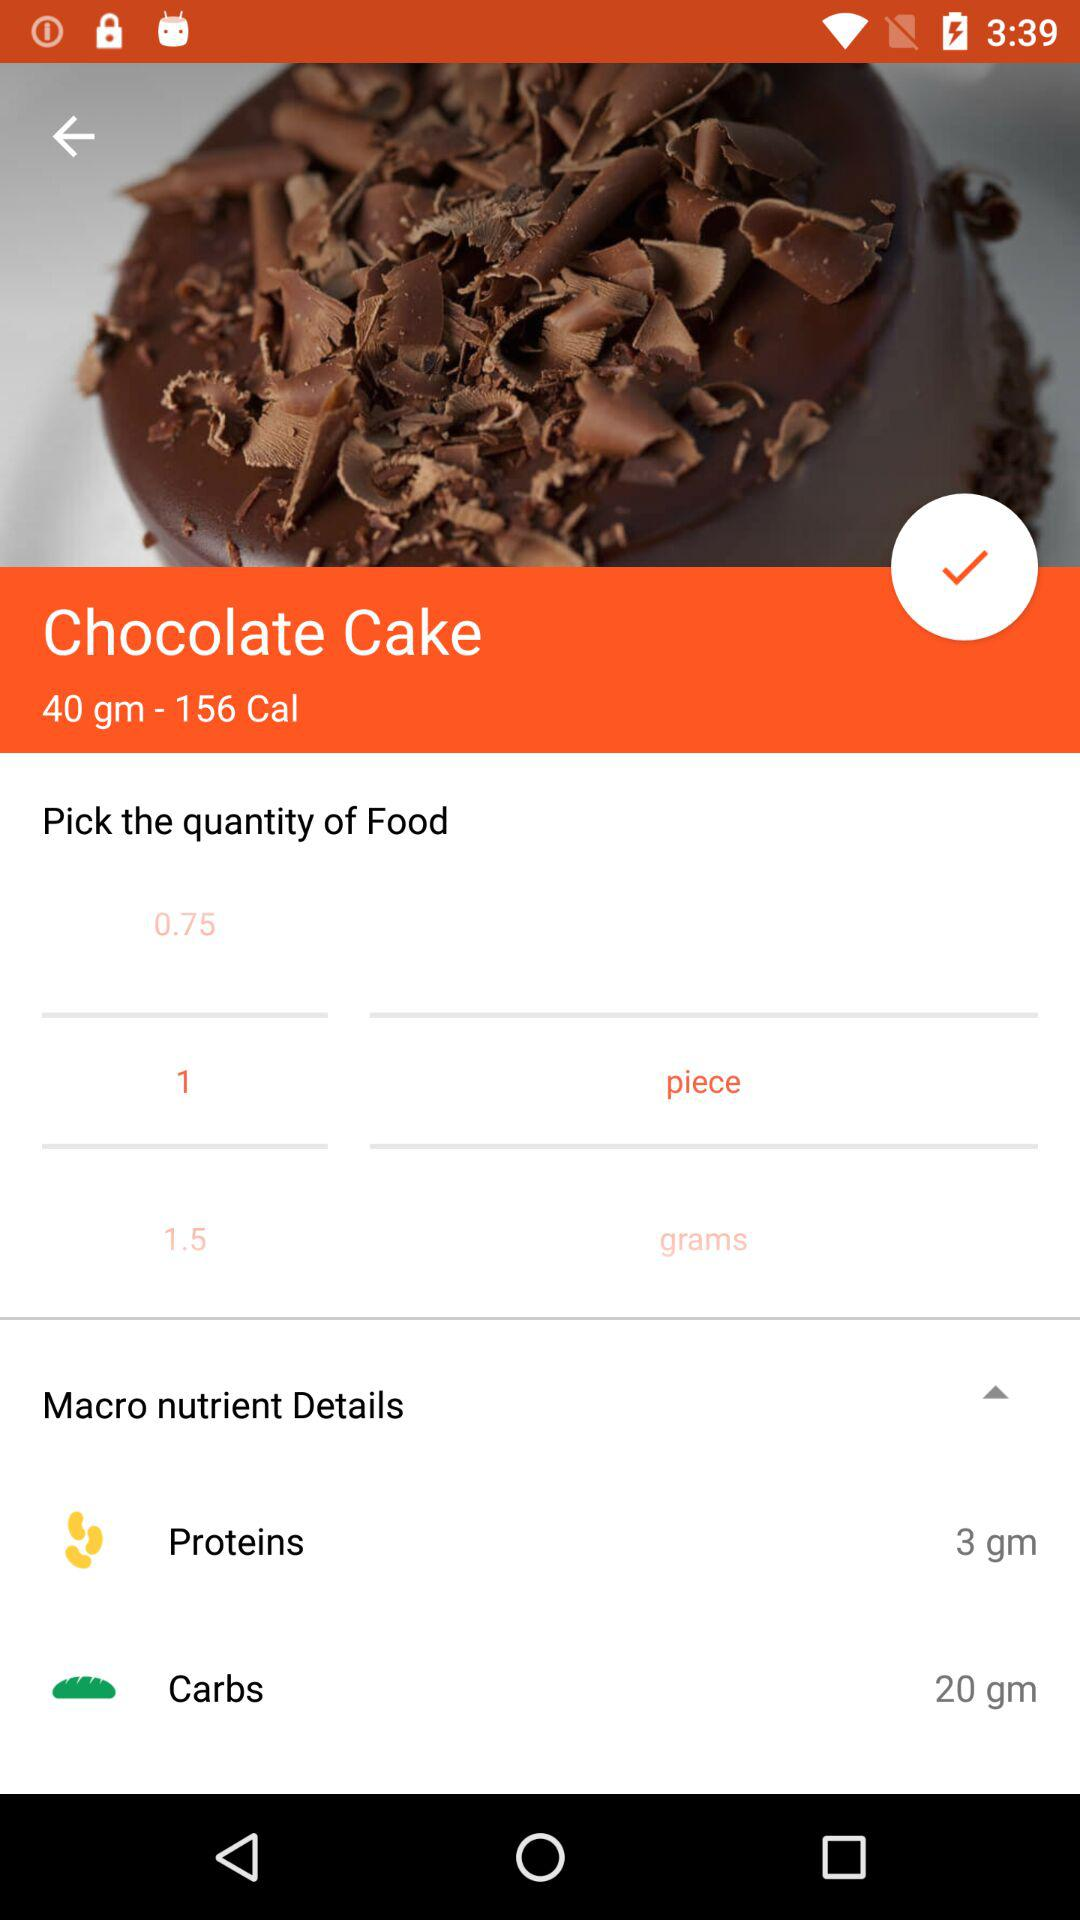How many calories are there in 1 piece of chocolate cake?
Answer the question using a single word or phrase. 156 